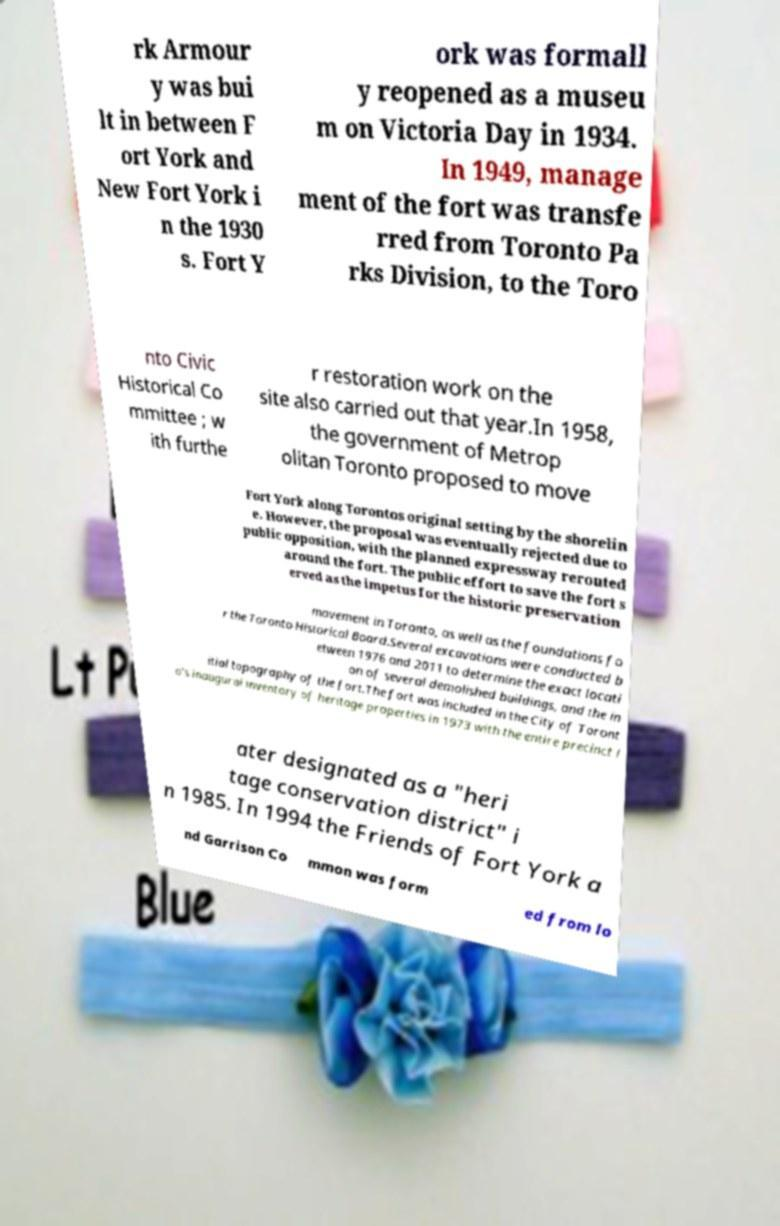Can you accurately transcribe the text from the provided image for me? rk Armour y was bui lt in between F ort York and New Fort York i n the 1930 s. Fort Y ork was formall y reopened as a museu m on Victoria Day in 1934. In 1949, manage ment of the fort was transfe rred from Toronto Pa rks Division, to the Toro nto Civic Historical Co mmittee ; w ith furthe r restoration work on the site also carried out that year.In 1958, the government of Metrop olitan Toronto proposed to move Fort York along Torontos original setting by the shorelin e. However, the proposal was eventually rejected due to public opposition, with the planned expressway rerouted around the fort. The public effort to save the fort s erved as the impetus for the historic preservation movement in Toronto, as well as the foundations fo r the Toronto Historical Board.Several excavations were conducted b etween 1976 and 2011 to determine the exact locati on of several demolished buildings, and the in itial topography of the fort.The fort was included in the City of Toront o's inaugural inventory of heritage properties in 1973 with the entire precinct l ater designated as a "heri tage conservation district" i n 1985. In 1994 the Friends of Fort York a nd Garrison Co mmon was form ed from lo 